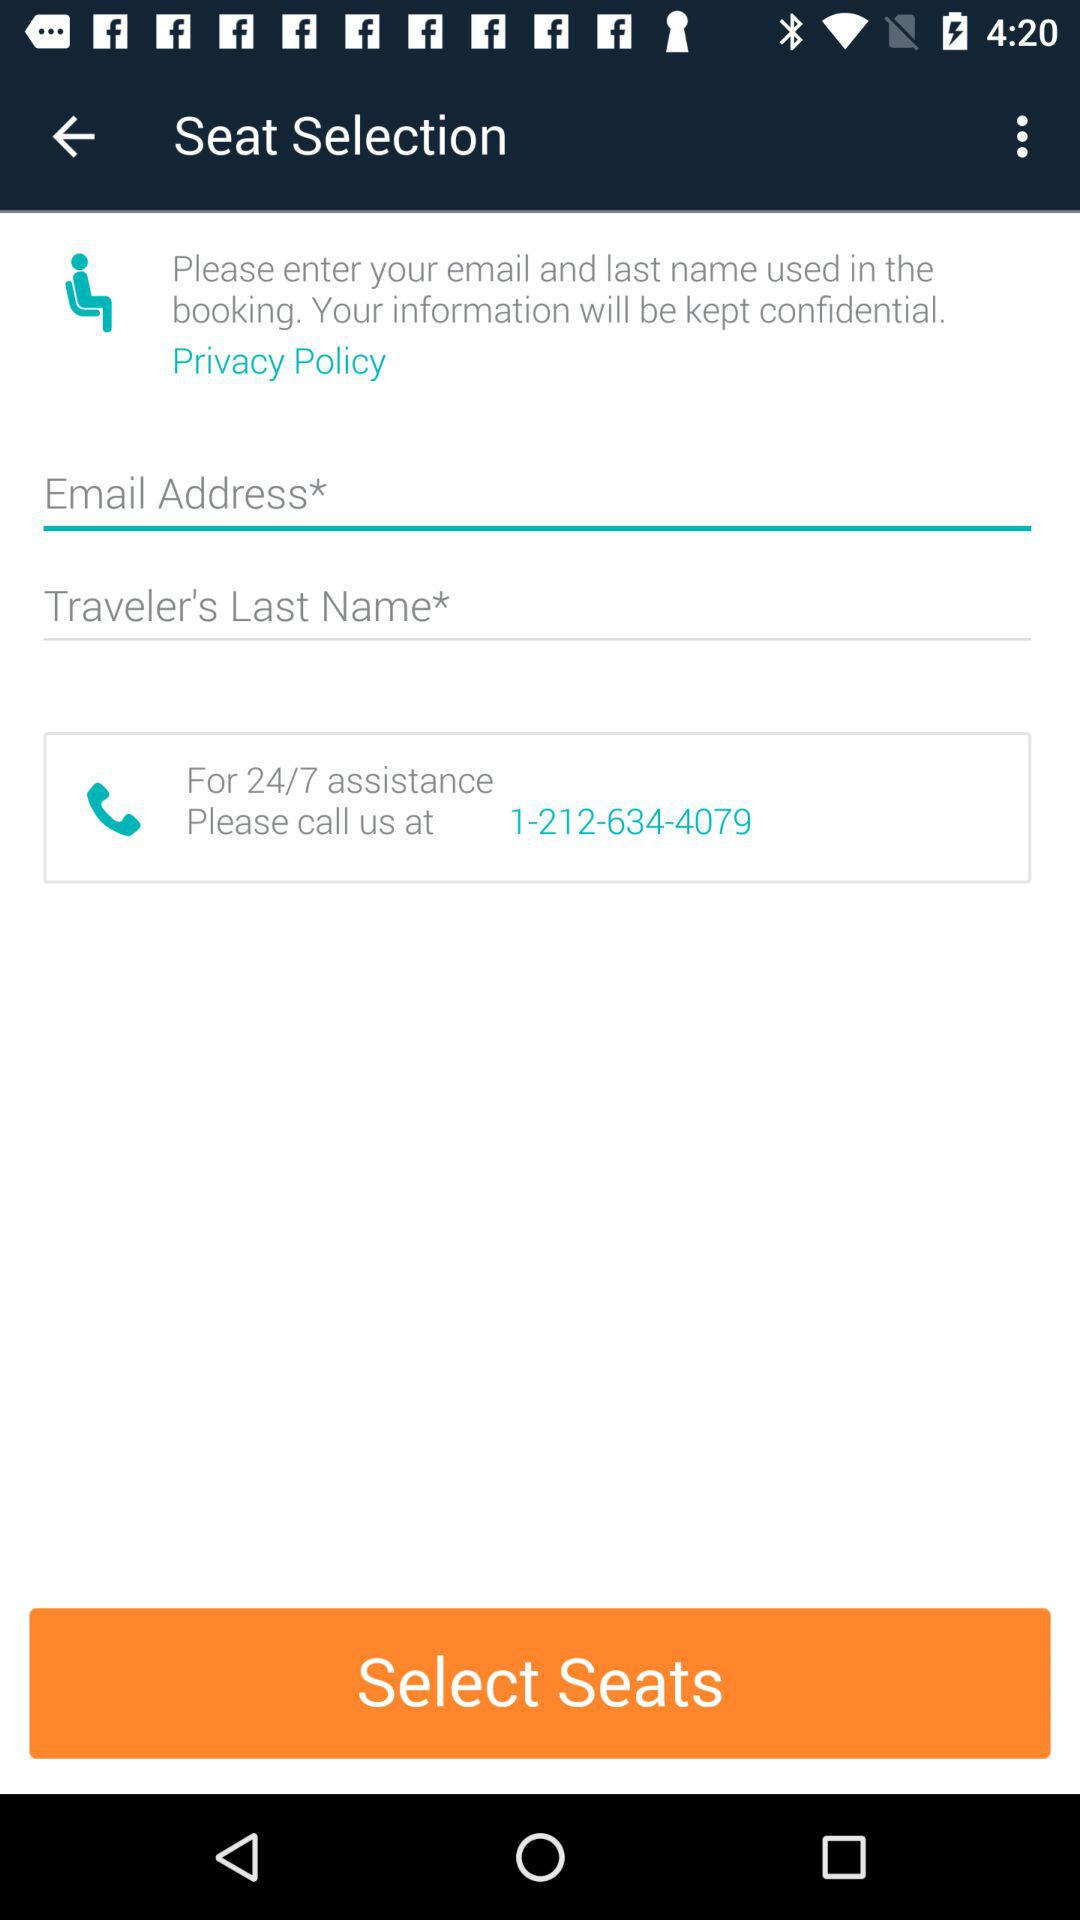What is the contact number "For 24/7 assistance"? The contact number is 1-212-634-4079. 